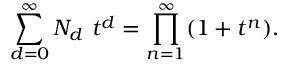<formula> <loc_0><loc_0><loc_500><loc_500>\sum _ { d = 0 } ^ { \infty } N _ { d } t ^ { d } = \prod _ { n = 1 } ^ { \infty } ( 1 + t ^ { n } ) .</formula> 